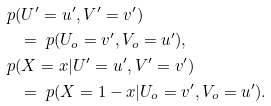<formula> <loc_0><loc_0><loc_500><loc_500>& \ p ( U ^ { \prime } = u ^ { \prime } , V ^ { \prime } = v ^ { \prime } ) \\ & \quad = \ p ( U _ { o } = v ^ { \prime } , V _ { o } = u ^ { \prime } ) , \\ & \ p ( X = x | U ^ { \prime } = u ^ { \prime } , V ^ { \prime } = v ^ { \prime } ) \\ & \quad = \ p ( X = 1 - x | U _ { o } = v ^ { \prime } , V _ { o } = u ^ { \prime } ) .</formula> 